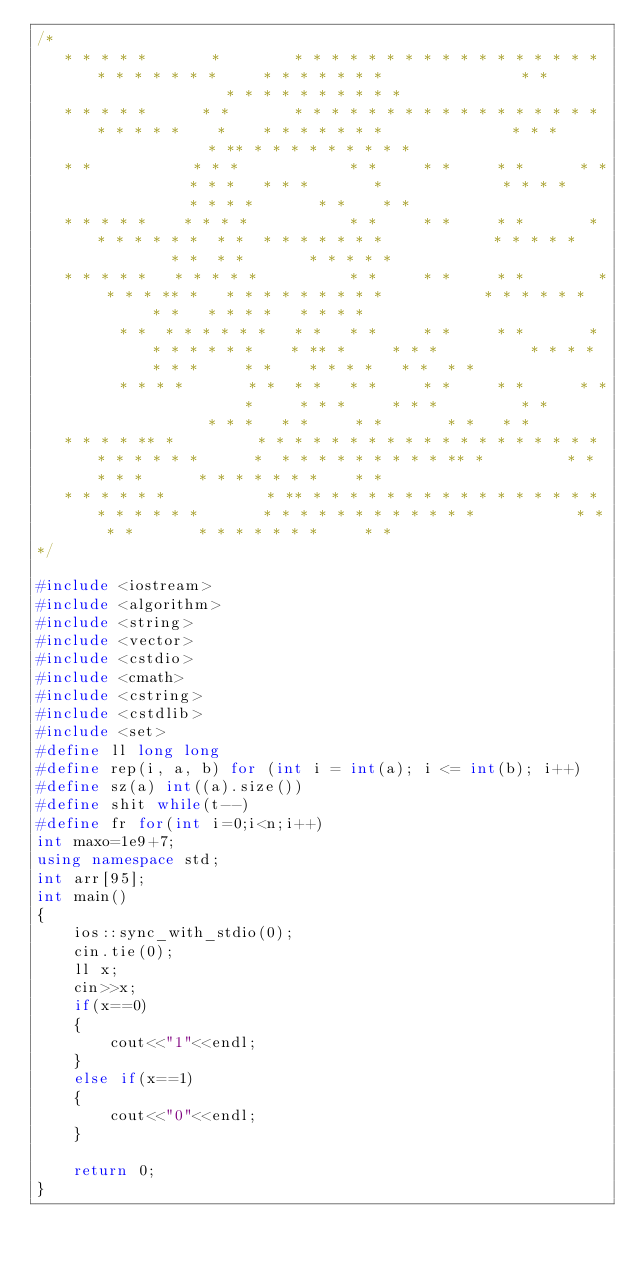<code> <loc_0><loc_0><loc_500><loc_500><_C++_>/*
   * * * * *       *        * * * * * * * * * * * * * * * * * * * * * * * *     * * * * * * *               * *               * * * * * * * * * *
   * * * * *      * *       * * * * * * * * * * * * * * * * * * * * * *    *    * * * * * * *              * * *             * ** * * * * * * * * *
   * *           * * *            * *     * *     * *      * *          * * *   * * *       *             * * * *           * * * *       * *    * *
   * * * * *    * * * *           * *     * *     * *       * * * * * * *  * *  * * * * * * *            * * * * *         * *  * *       * * * * *
   * * * * *   * * * * *          * *     * *     * *        * * * * ** *   * * * * * * * * *           * * * * * *       * *   * * * *   * * * *
         * *  * * * * * *   * *   * *     * *     * *       * * * * * * *    * ** *     * * *          * * * * * * *     * *    * * * *   * *  * *
         * * * *       * *  * *   * *     * *     * *      * *          *     * * *     * * *         * *       * * *   * *     * *       * *   * *
   * * * * ** *         * * * * * * * * * * * * * * * * * * * * * * * * *      *  * * * * * * * * * ** *         * * * * *      * * * * * * *    * *
   * * * * * *           * ** * * * * * * * * * * * * * * * * * * * * * *       * * * * * * * * * * * *           * * * *       * * * * * * *     * *
*/
 
#include <iostream>
#include <algorithm>
#include <string>
#include <vector>
#include <cstdio>
#include <cmath>
#include <cstring>
#include <cstdlib>
#include <set>
#define ll long long
#define rep(i, a, b) for (int i = int(a); i <= int(b); i++)
#define sz(a) int((a).size())
#define shit while(t--)
#define fr for(int i=0;i<n;i++)
int maxo=1e9+7;
using namespace std;
int arr[95];
int main()
{
    ios::sync_with_stdio(0);
    cin.tie(0);
    ll x;
    cin>>x;
    if(x==0)
    {
        cout<<"1"<<endl;
    }
    else if(x==1)
    {
        cout<<"0"<<endl;
    }
 
    return 0;
}</code> 